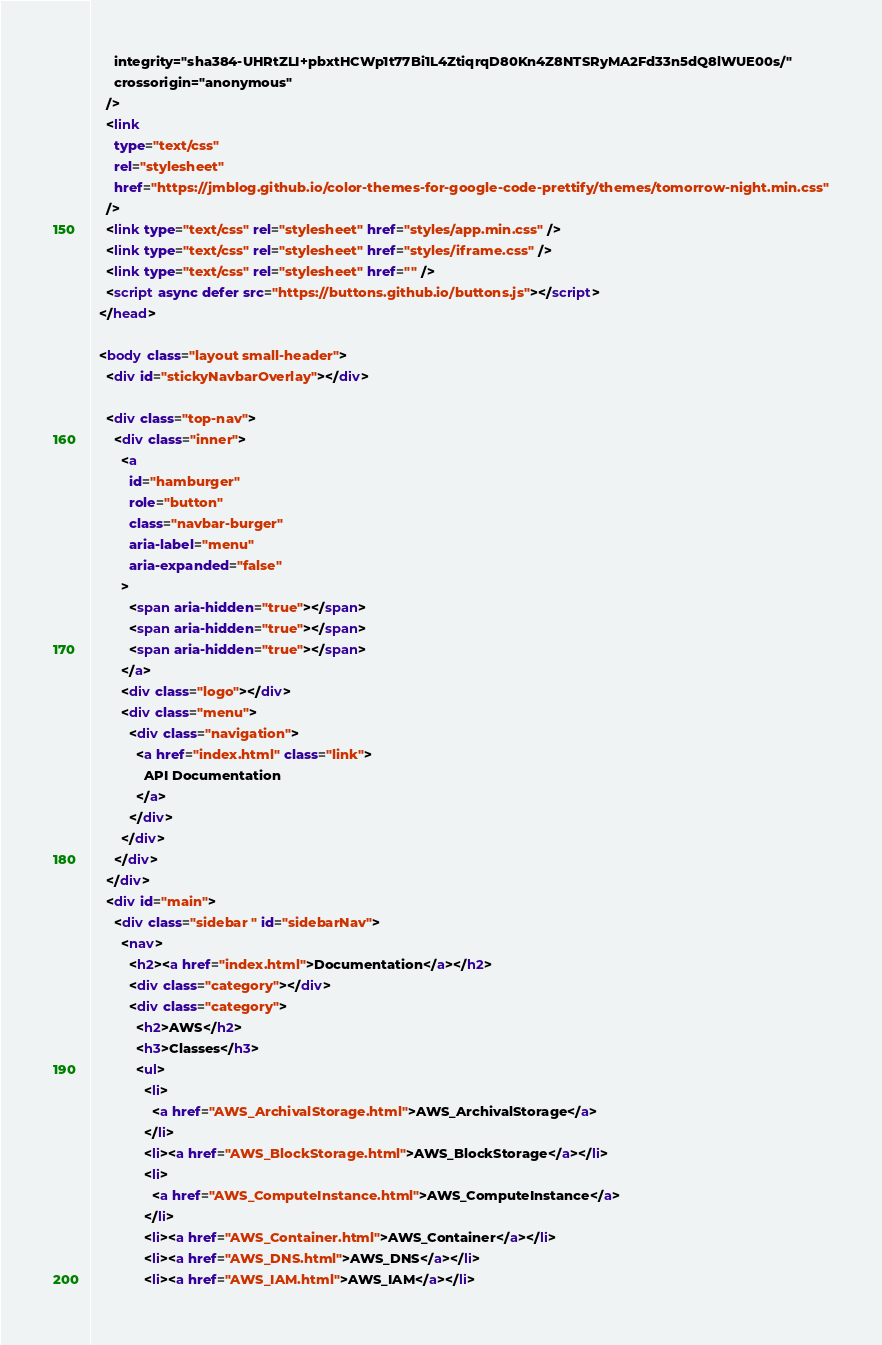<code> <loc_0><loc_0><loc_500><loc_500><_HTML_>      integrity="sha384-UHRtZLI+pbxtHCWp1t77Bi1L4ZtiqrqD80Kn4Z8NTSRyMA2Fd33n5dQ8lWUE00s/"
      crossorigin="anonymous"
    />
    <link
      type="text/css"
      rel="stylesheet"
      href="https://jmblog.github.io/color-themes-for-google-code-prettify/themes/tomorrow-night.min.css"
    />
    <link type="text/css" rel="stylesheet" href="styles/app.min.css" />
    <link type="text/css" rel="stylesheet" href="styles/iframe.css" />
    <link type="text/css" rel="stylesheet" href="" />
    <script async defer src="https://buttons.github.io/buttons.js"></script>
  </head>

  <body class="layout small-header">
    <div id="stickyNavbarOverlay"></div>

    <div class="top-nav">
      <div class="inner">
        <a
          id="hamburger"
          role="button"
          class="navbar-burger"
          aria-label="menu"
          aria-expanded="false"
        >
          <span aria-hidden="true"></span>
          <span aria-hidden="true"></span>
          <span aria-hidden="true"></span>
        </a>
        <div class="logo"></div>
        <div class="menu">
          <div class="navigation">
            <a href="index.html" class="link">
              API Documentation
            </a>
          </div>
        </div>
      </div>
    </div>
    <div id="main">
      <div class="sidebar " id="sidebarNav">
        <nav>
          <h2><a href="index.html">Documentation</a></h2>
          <div class="category"></div>
          <div class="category">
            <h2>AWS</h2>
            <h3>Classes</h3>
            <ul>
              <li>
                <a href="AWS_ArchivalStorage.html">AWS_ArchivalStorage</a>
              </li>
              <li><a href="AWS_BlockStorage.html">AWS_BlockStorage</a></li>
              <li>
                <a href="AWS_ComputeInstance.html">AWS_ComputeInstance</a>
              </li>
              <li><a href="AWS_Container.html">AWS_Container</a></li>
              <li><a href="AWS_DNS.html">AWS_DNS</a></li>
              <li><a href="AWS_IAM.html">AWS_IAM</a></li></code> 